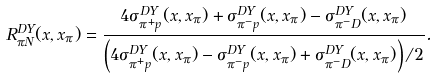Convert formula to latex. <formula><loc_0><loc_0><loc_500><loc_500>R ^ { D Y } _ { \pi N } ( x , x _ { \pi } ) = \frac { 4 \sigma _ { \pi ^ { + } p } ^ { D Y } ( x , x _ { \pi } ) + \sigma _ { \pi ^ { - } p } ^ { D Y } ( x , x _ { \pi } ) - \sigma _ { \pi ^ { - } D } ^ { D Y } ( x , x _ { \pi } ) } { \left ( 4 \sigma _ { \pi ^ { + } p } ^ { D Y } ( x , x _ { \pi } ) - \sigma _ { \pi ^ { - } p } ^ { D Y } ( x , x _ { \pi } ) + \sigma _ { \pi ^ { - } D } ^ { D Y } ( x , x _ { \pi } ) \right ) / 2 } .</formula> 